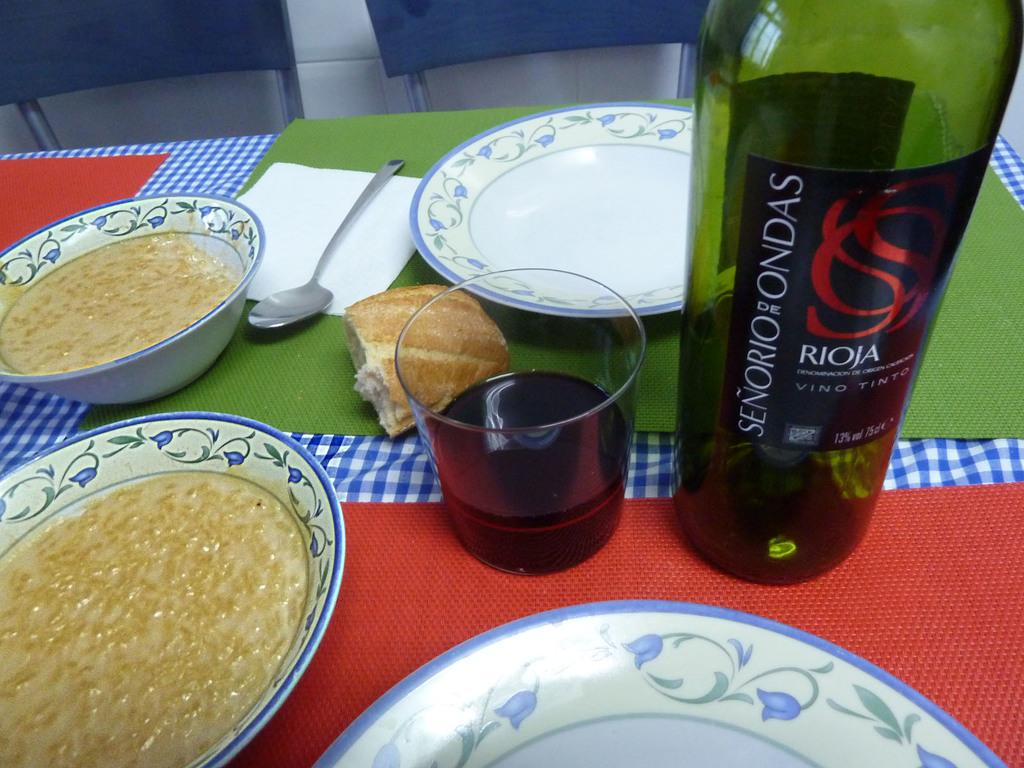<image>
Relay a brief, clear account of the picture shown. A dining table with food and a bottle of senorio de ondas wine. 